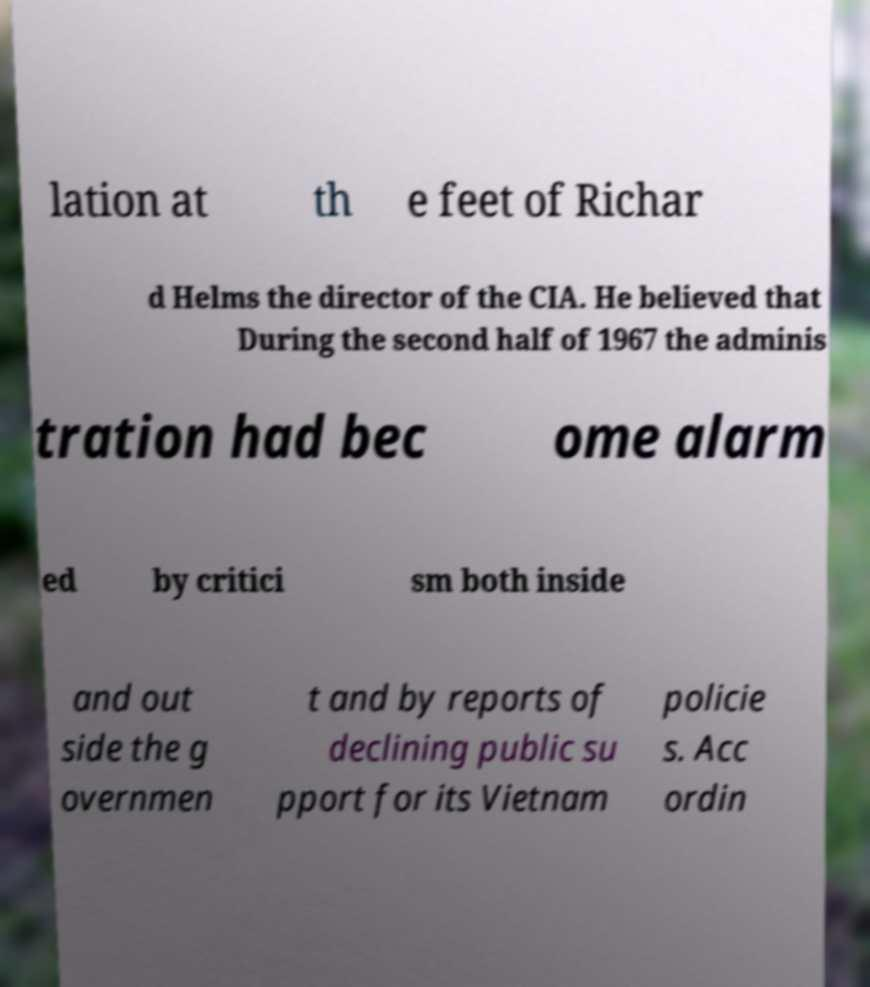What messages or text are displayed in this image? I need them in a readable, typed format. lation at th e feet of Richar d Helms the director of the CIA. He believed that During the second half of 1967 the adminis tration had bec ome alarm ed by critici sm both inside and out side the g overnmen t and by reports of declining public su pport for its Vietnam policie s. Acc ordin 